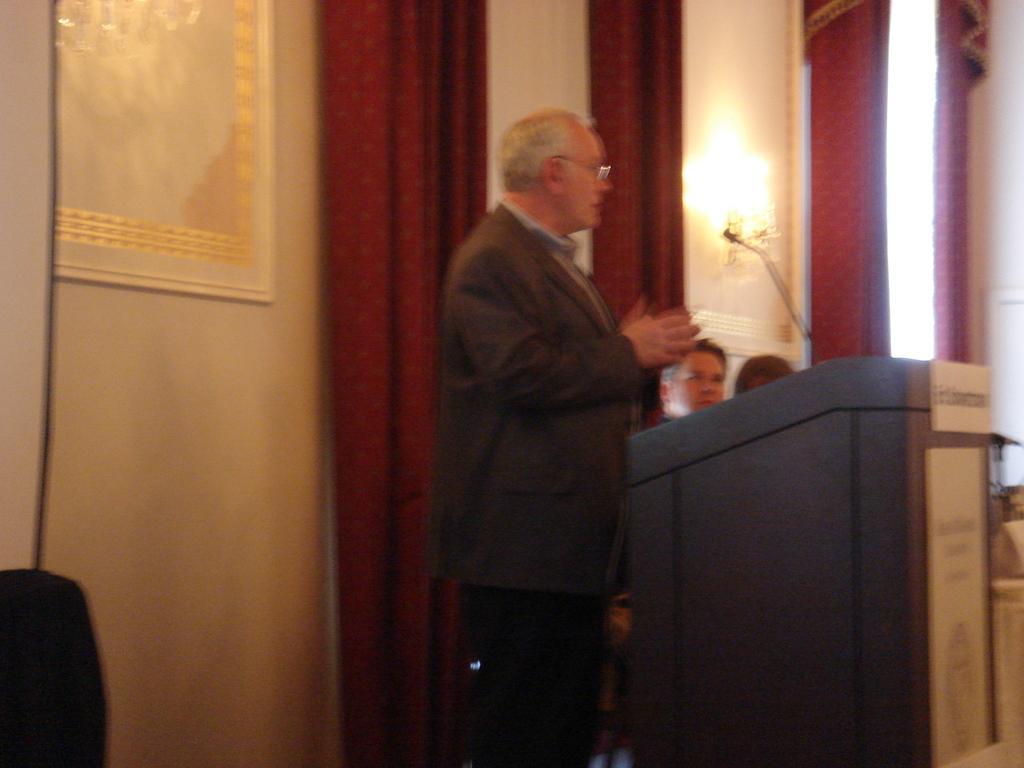In one or two sentences, can you explain what this image depicts? In this picture, we can see a few people, podium, microphones, and we can see the wall with some objects attached like curtains, lights, and frames, we can see some object in the bottom left side of the picture. 